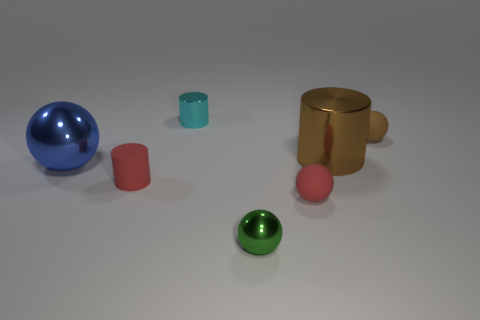Subtract all tiny spheres. How many spheres are left? 1 Add 2 blue matte blocks. How many objects exist? 9 Subtract all purple cylinders. Subtract all red spheres. How many cylinders are left? 3 Subtract all blue spheres. How many gray cylinders are left? 0 Subtract all large brown things. Subtract all tiny matte things. How many objects are left? 3 Add 5 small spheres. How many small spheres are left? 8 Add 6 red matte cylinders. How many red matte cylinders exist? 7 Subtract all brown cylinders. How many cylinders are left? 2 Subtract 0 green cylinders. How many objects are left? 7 Subtract all spheres. How many objects are left? 3 